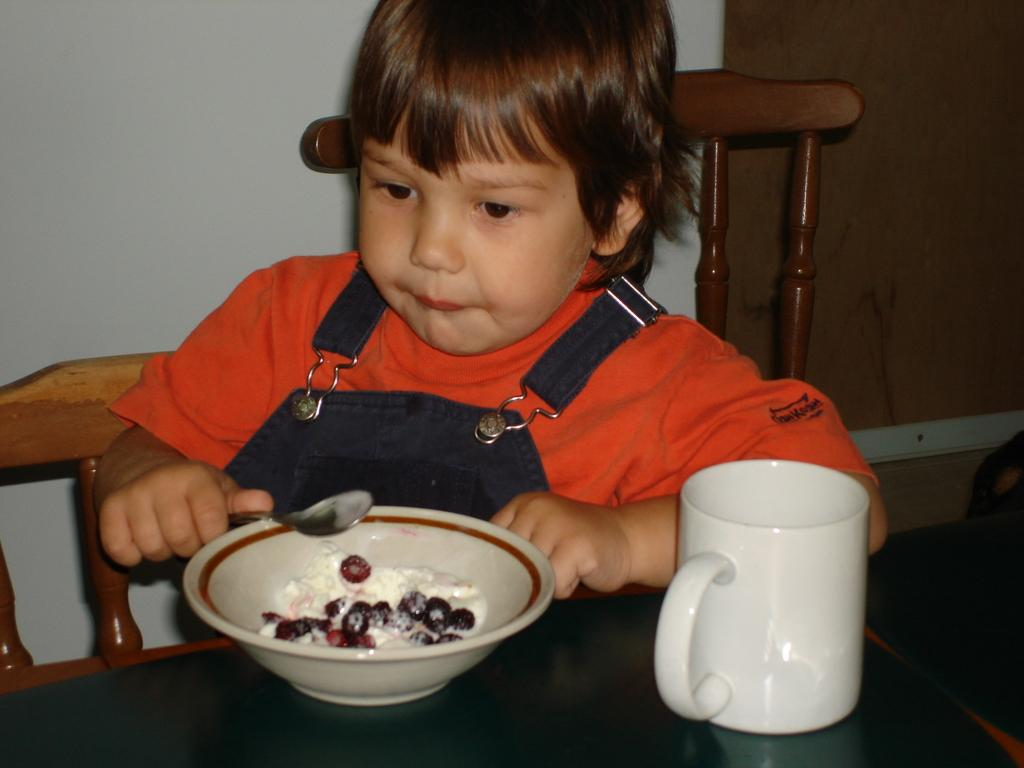What is the main subject of the image? There is a boy in the image. What is the boy wearing? The boy is wearing an orange t-shirt. What is the boy holding in his hand? The boy is holding a spoon in his hand. What objects are on the table in the image? There is a bowl and a cup on the table. What is the boy's position in the image? The boy is sitting on a chair. What type of bead is the boy using to teach the cup in the image? There is no bead or teaching activity present in the image. Can you hear the whistle the boy is playing in the image? There is no whistle or indication of sound in the image. 